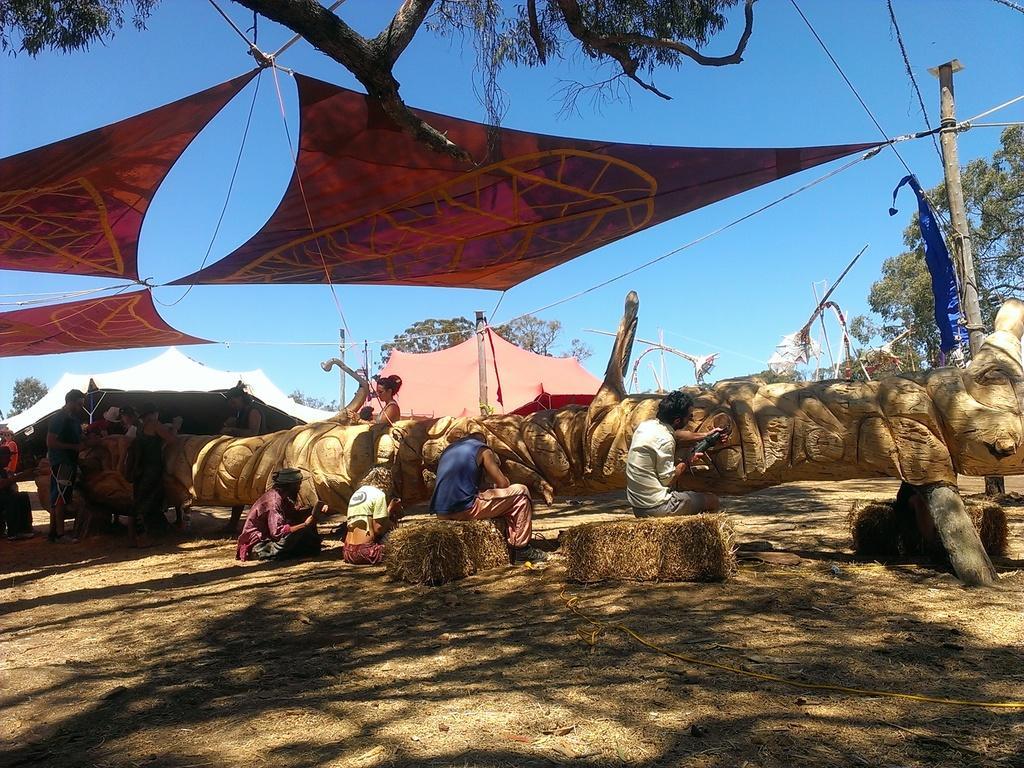How would you summarize this image in a sentence or two? In this picture we can see a few people sitting on a dry grass. There are some people sitting on the ground. We can see a few people on the left side. There are tents. We can see ropes, wire and a pole on the right side. There are a few trees in the background. Sky is blue in color. 